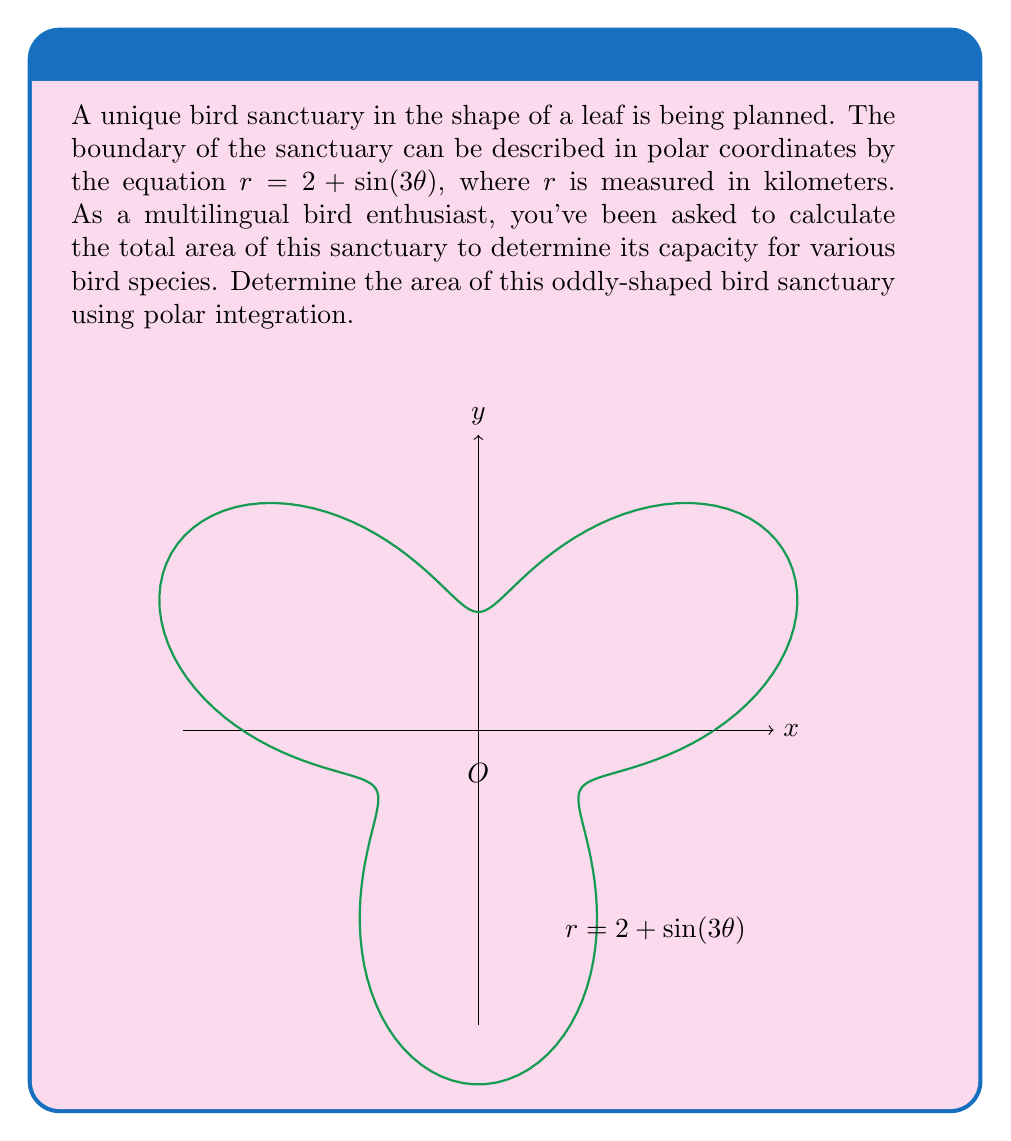Solve this math problem. Let's approach this step-by-step:

1) The formula for the area of a region in polar coordinates is:

   $$A = \frac{1}{2} \int_a^b r^2(\theta) d\theta$$

2) In this case, $r(\theta) = 2 + \sin(3\theta)$, and we need to integrate over the full range of $\theta$, from 0 to $2\pi$.

3) Let's square $r(\theta)$:

   $$r^2(\theta) = (2 + \sin(3\theta))^2 = 4 + 4\sin(3\theta) + \sin^2(3\theta)$$

4) Now we can set up our integral:

   $$A = \frac{1}{2} \int_0^{2\pi} (4 + 4\sin(3\theta) + \sin^2(3\theta)) d\theta$$

5) Let's integrate each term separately:

   a) $\int_0^{2\pi} 4 d\theta = 4\theta \Big|_0^{2\pi} = 8\pi$

   b) $\int_0^{2\pi} 4\sin(3\theta) d\theta = -\frac{4}{3}\cos(3\theta) \Big|_0^{2\pi} = 0$

   c) For $\int_0^{2\pi} \sin^2(3\theta) d\theta$, we can use the identity $\sin^2 x = \frac{1-\cos(2x)}{2}$:

      $\int_0^{2\pi} \sin^2(3\theta) d\theta = \int_0^{2\pi} \frac{1-\cos(6\theta)}{2} d\theta$
      $= \frac{1}{2}\theta - \frac{1}{12}\sin(6\theta) \Big|_0^{2\pi} = \pi$

6) Adding these results:

   $$A = \frac{1}{2}(8\pi + 0 + \pi) = \frac{9\pi}{2}$$

7) Therefore, the area of the bird sanctuary is $\frac{9\pi}{2}$ square kilometers.
Answer: $\frac{9\pi}{2}$ km² 